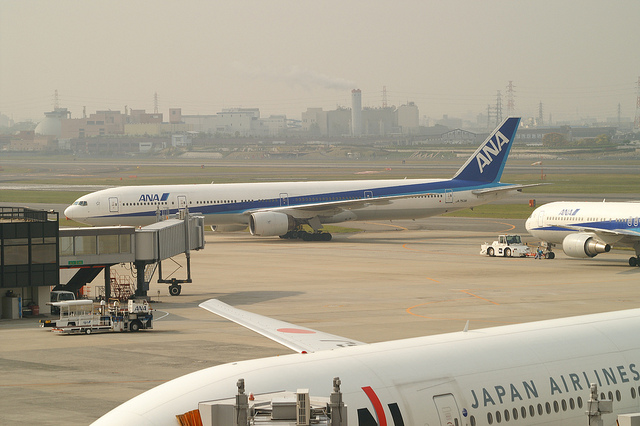Is this image taken during the day or night? This image is taken during the day, as evident from the natural light and visibility of the surroundings. Can you tell anything about the weather conditions from the image? The weather appears to be hazy or slightly overcast, with no clear signs of immediate precipitation. The visibility is good, and there are no shadows indicating strong sunlight, which suggests it might be mostly cloudy. 